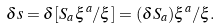Convert formula to latex. <formula><loc_0><loc_0><loc_500><loc_500>\delta s = \delta [ S _ { a } \, \xi ^ { a } / \xi ] = ( \delta S _ { a } ) \xi ^ { a } / \xi .</formula> 